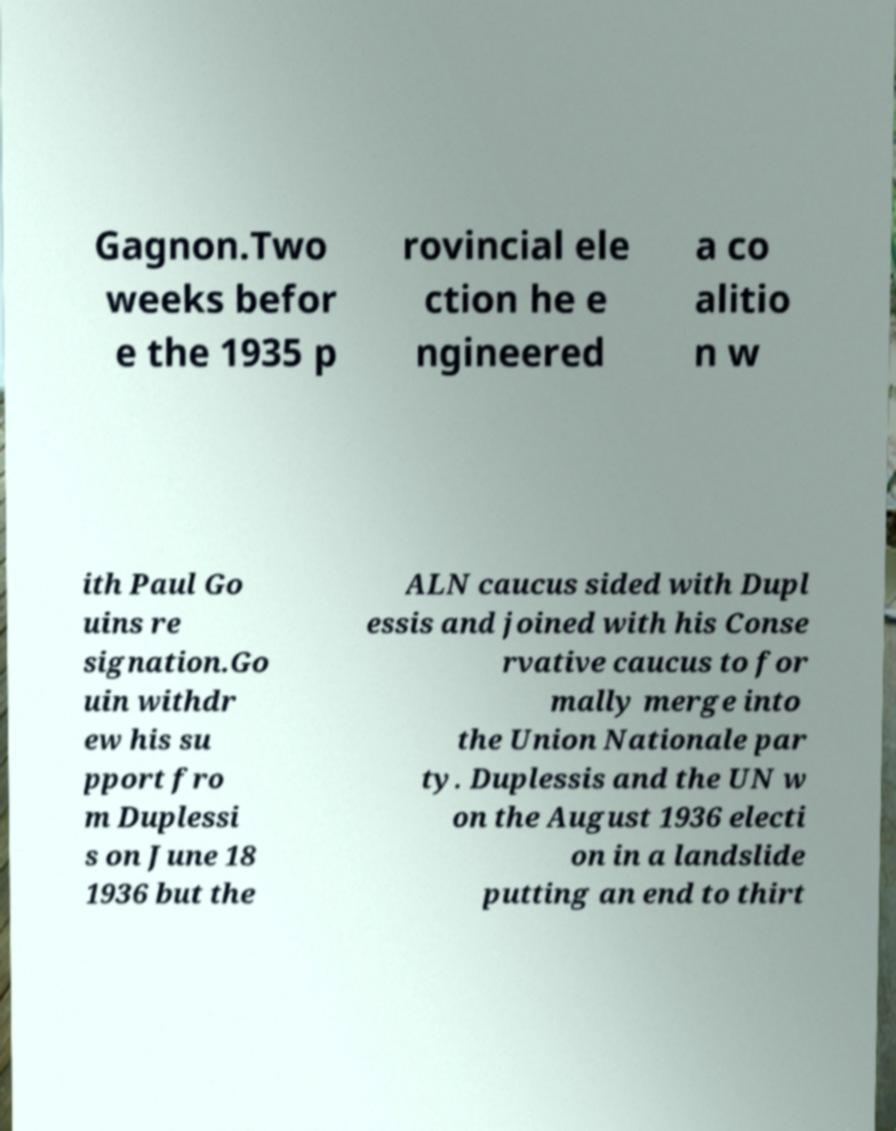Please read and relay the text visible in this image. What does it say? Gagnon.Two weeks befor e the 1935 p rovincial ele ction he e ngineered a co alitio n w ith Paul Go uins re signation.Go uin withdr ew his su pport fro m Duplessi s on June 18 1936 but the ALN caucus sided with Dupl essis and joined with his Conse rvative caucus to for mally merge into the Union Nationale par ty. Duplessis and the UN w on the August 1936 electi on in a landslide putting an end to thirt 